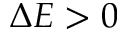Convert formula to latex. <formula><loc_0><loc_0><loc_500><loc_500>\Delta E > 0</formula> 